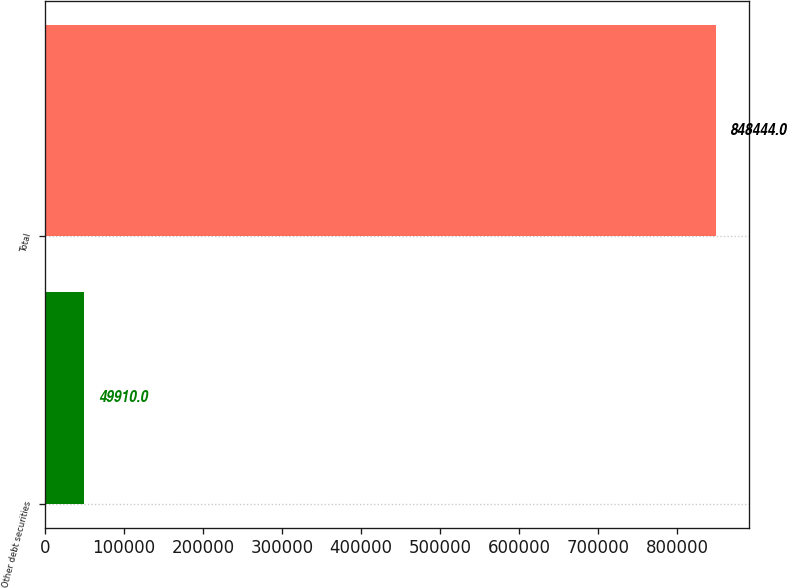Convert chart to OTSL. <chart><loc_0><loc_0><loc_500><loc_500><bar_chart><fcel>Other debt securities<fcel>Total<nl><fcel>49910<fcel>848444<nl></chart> 